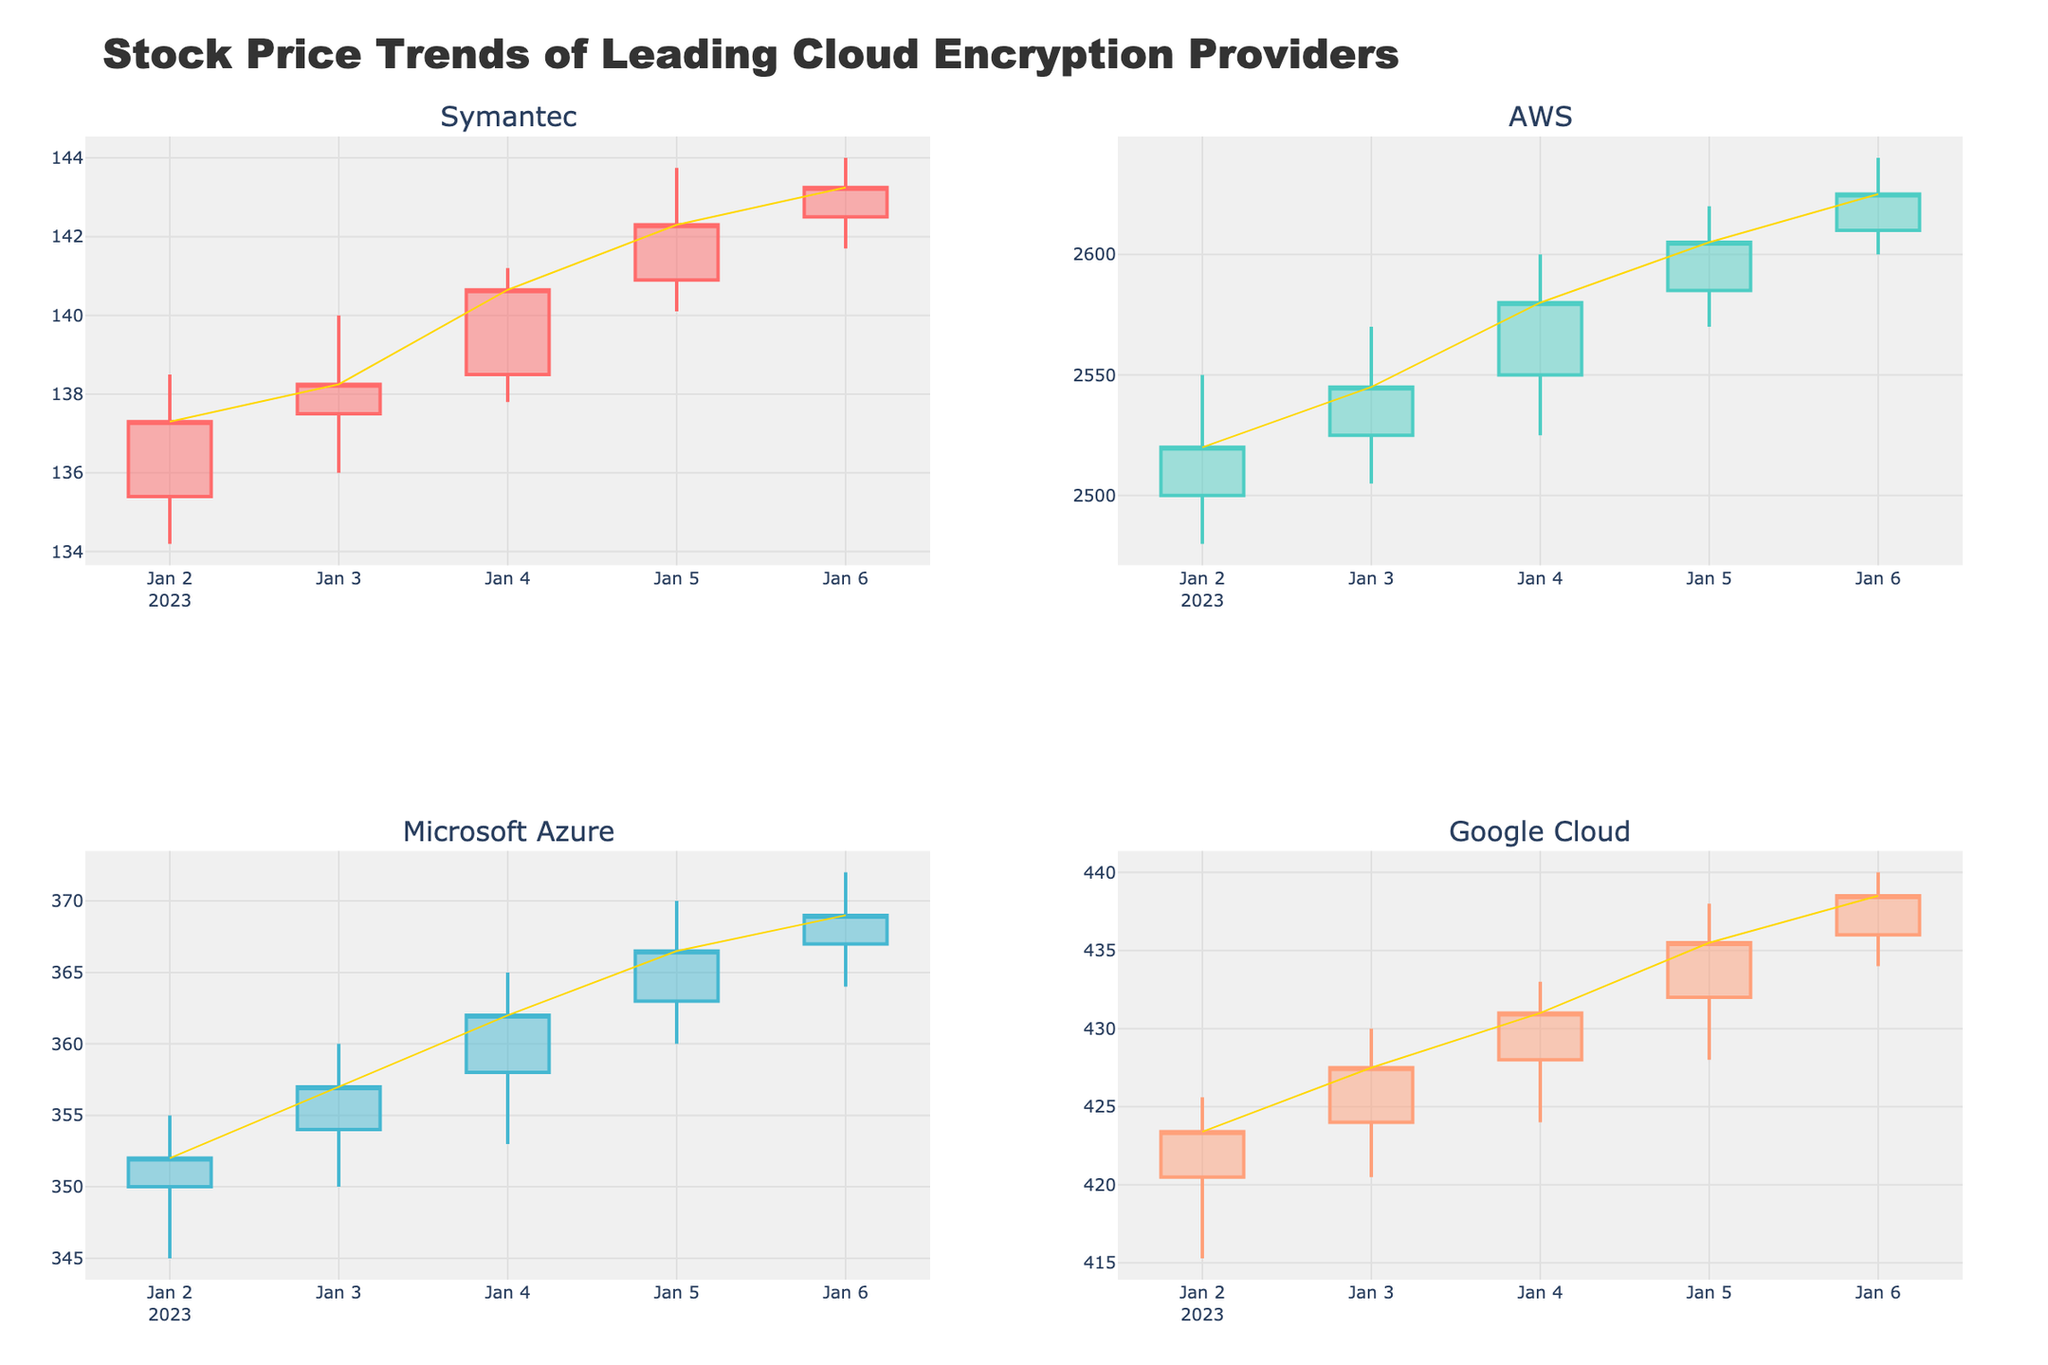What is the overall trend of Symantec's stock prices during the given period? Observing the candlestick plot for Symantec, we see that the closing prices show a rising trend from January 2nd (137.30) to January 6th (143.25).
Answer: Upward Which company has the highest closing price on January 3, 2023? By looking at the closing prices on January 3rd for each company on the candlestick plot, AWS has the highest closing price of 2545.00.
Answer: AWS How does Microsoft's closing price on January 4th compare to Google's on the same day? From the candlestick plot, Microsoft's closing price on January 4th is 362.00, while Google's closing price on the same day is 431.00. Comparing these, Google's closing price is higher.
Answer: Google's is higher What is the average closing price of AWS over the given period? Add up the closing prices of AWS from January 2nd to January 6th (2520.00 + 2545.00 + 2580.00 + 2605.00 + 2625.00) which equals 12875.00. Dividing this sum by 5 (the number of days), we get 2575.00.
Answer: 2575.00 Which day did Microsoft Azure experience the highest trading volume? Checking the volume information for Microsoft Azure in the candlestick plot, we see the highest trading volume is on January 6th with a volume of 2,350,000.
Answer: January 6th Compare the trend of Google's stock prices to that of Symantec's during the given period. By comparing the trends shown in the candlestick plots, both Google and Symantec show an overall upward trend in their stock prices from January 2nd to January 6th.
Answer: Both upward Which company's stock price had the least volatility during the given period? Volatility can be observed through the candlestick lengths. Symantec's candlesticks are relatively shorter in comparison to others, indicating less volatility.
Answer: Symantec What are the highest and lowest prices for AWS on January 4, 2023? Looking at the candlestick for AWS on January 4th, the highest price is 2600.00 and the lowest price is 2525.00.
Answer: Highest: 2600.00, Lowest: 2525.00 On which day was Symantec's closing price closest to Google's closing price? By comparing the closing prices of Symantec and Google, on January 6th Symantec's closing price (143.25) is the closest to Google's closing price (438.50).
Answer: January 6th 